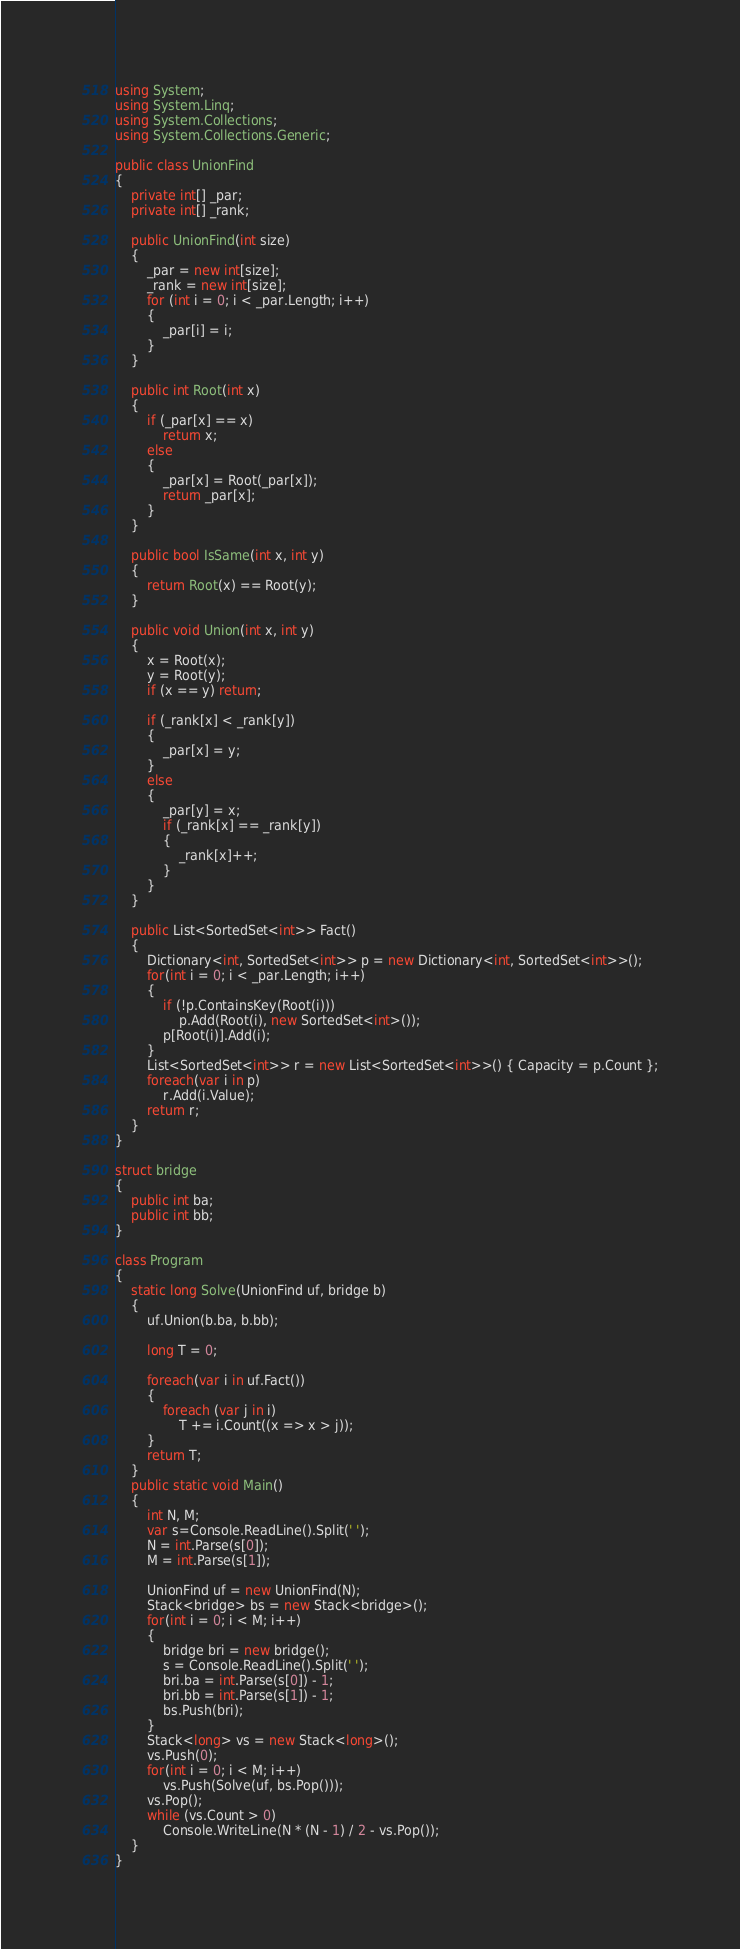Convert code to text. <code><loc_0><loc_0><loc_500><loc_500><_C#_>using System;
using System.Linq;
using System.Collections;
using System.Collections.Generic;

public class UnionFind
{
    private int[] _par;
    private int[] _rank;

    public UnionFind(int size)
    {
        _par = new int[size];
        _rank = new int[size];
        for (int i = 0; i < _par.Length; i++)
        {
            _par[i] = i;
        }
    }

    public int Root(int x)
    {
        if (_par[x] == x)
            return x;
        else
        {
            _par[x] = Root(_par[x]);
            return _par[x];
        }
    }

    public bool IsSame(int x, int y)
    {
        return Root(x) == Root(y);
    }

    public void Union(int x, int y)
    {
        x = Root(x);
        y = Root(y);
        if (x == y) return;

        if (_rank[x] < _rank[y])
        {
            _par[x] = y;
        }
        else
        {
            _par[y] = x;
            if (_rank[x] == _rank[y])
            {
                _rank[x]++;
            }
        }
    }

    public List<SortedSet<int>> Fact()
    {
        Dictionary<int, SortedSet<int>> p = new Dictionary<int, SortedSet<int>>();
        for(int i = 0; i < _par.Length; i++)
        {
            if (!p.ContainsKey(Root(i)))
                p.Add(Root(i), new SortedSet<int>());
            p[Root(i)].Add(i);
        }
        List<SortedSet<int>> r = new List<SortedSet<int>>() { Capacity = p.Count };
        foreach(var i in p)
            r.Add(i.Value);
        return r;
    }
}

struct bridge
{
    public int ba;
    public int bb;
}

class Program
{
    static long Solve(UnionFind uf, bridge b)
    {
        uf.Union(b.ba, b.bb);

        long T = 0;

        foreach(var i in uf.Fact())
        {
            foreach (var j in i)
                T += i.Count((x => x > j));
        }
        return T;
    }
    public static void Main()
    {
        int N, M;
        var s=Console.ReadLine().Split(' ');
        N = int.Parse(s[0]);
        M = int.Parse(s[1]);

        UnionFind uf = new UnionFind(N);
        Stack<bridge> bs = new Stack<bridge>();
        for(int i = 0; i < M; i++)
        {
            bridge bri = new bridge();
            s = Console.ReadLine().Split(' ');
            bri.ba = int.Parse(s[0]) - 1;
            bri.bb = int.Parse(s[1]) - 1;
            bs.Push(bri);
        }
        Stack<long> vs = new Stack<long>();
        vs.Push(0);
        for(int i = 0; i < M; i++)
            vs.Push(Solve(uf, bs.Pop()));
        vs.Pop();
        while (vs.Count > 0)
            Console.WriteLine(N * (N - 1) / 2 - vs.Pop());
    }
}</code> 